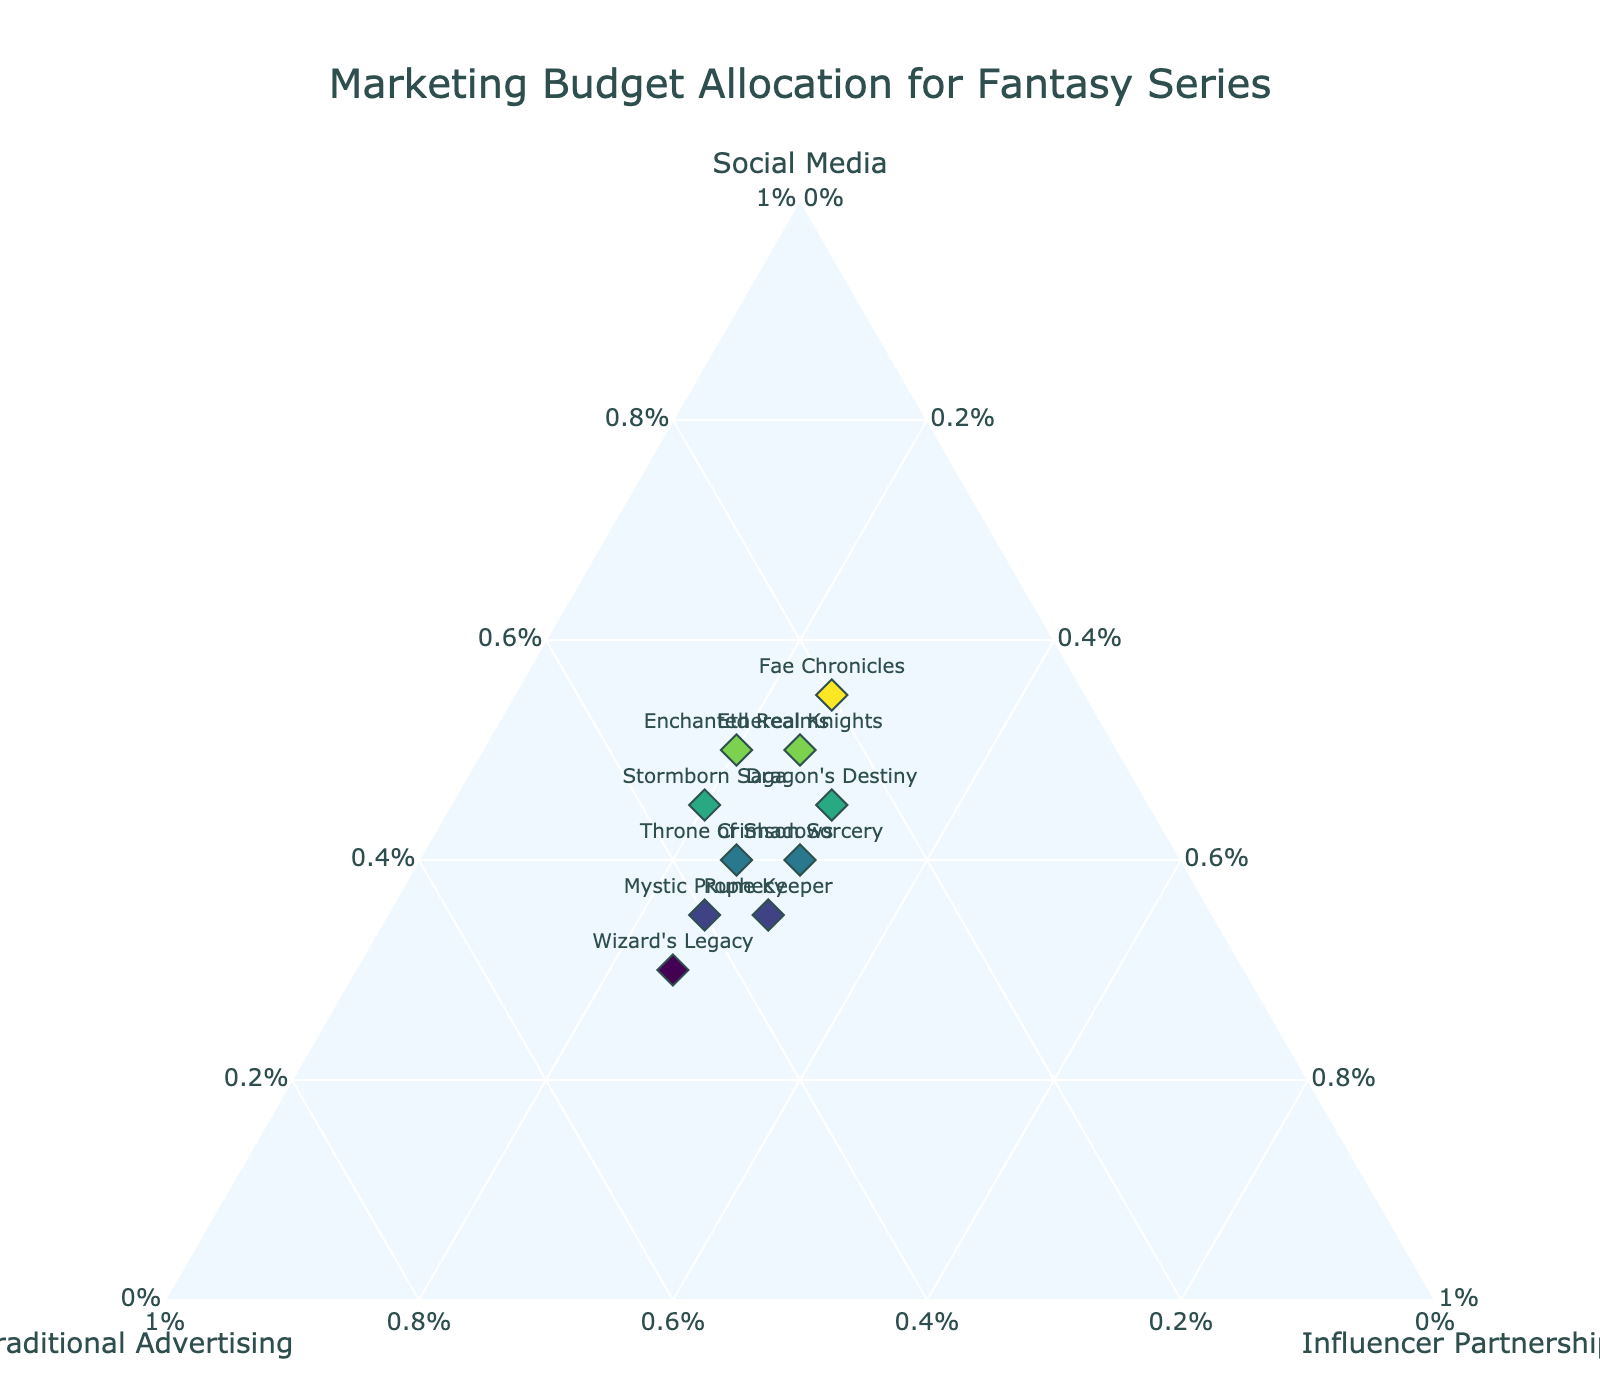What's the title of the figure? The title can be found at the top of the figure. It provides a summary of the data being visualized.
Answer: Marketing Budget Allocation for Fantasy Series How many campaigns are plotted on the figure? To find this, one would count the number of markers on the ternary plot, as each marker represents a campaign.
Answer: 10 Which campaign allocates the highest percentage to Social Media? Look for the campaign positioned closest to the Social Media axis. This position indicates a higher percentage allocation towards Social Media.
Answer: Fae Chronicles Among the campaigns, which one has the smallest percentage allocation for Traditional Advertising? Identify the campaign closest to the base of the Traditional Advertising axis; this suggests the smallest percentage allocation.
Answer: Fae Chronicles What is the percentage allocation breakdown for Dragon's Destiny? Locate Dragon's Destiny on the plot and refer to the hover information for the specific percent breakdowns in each category.
Answer: Social Media: 45%, Traditional Advertising: 25%, Influencer Partnerships: 30% Which campaigns have the same percentage allocation for Influencer Partnerships? Locate the campaigns that share the same position relative to the Influencer Partnerships axis. Check the hover information for additional confirmation.
Answer: Throne of Shadows, Mystic Prophecy, Stormborn Saga, Ethereal Knights, Wizard's Legacy What is the average percentage allocation for Social Media across all campaigns? Sum up the Social Media percentages and divide by the number of campaigns: (40+50+45+35+55+30+40+50+45+35)/10 = 42.5%
Answer: 42.5% Compare the Social Media and Traditional Advertising allocations for Rune Keeper. Which is higher and by how much? Look at the hover information for Rune Keeper and subtract the percentage for Traditional Advertising from Social Media. Social Media: 35%, Traditional Advertising: 35%. Difference: 35% - 35% = 0%.
Answer: Equal Which campaign has the most balanced allocation among the three categories? Look for the campaign closest to the center of the ternary plot, indicating similar percentages across all categories.
Answer: Crimson Sorcery For which campaigns is Traditional Advertising the highest allocation? Identify campaigns closest to the Traditional Advertising axis's apex.
Answer: Wizard's Legacy, Mystic Prophecy 